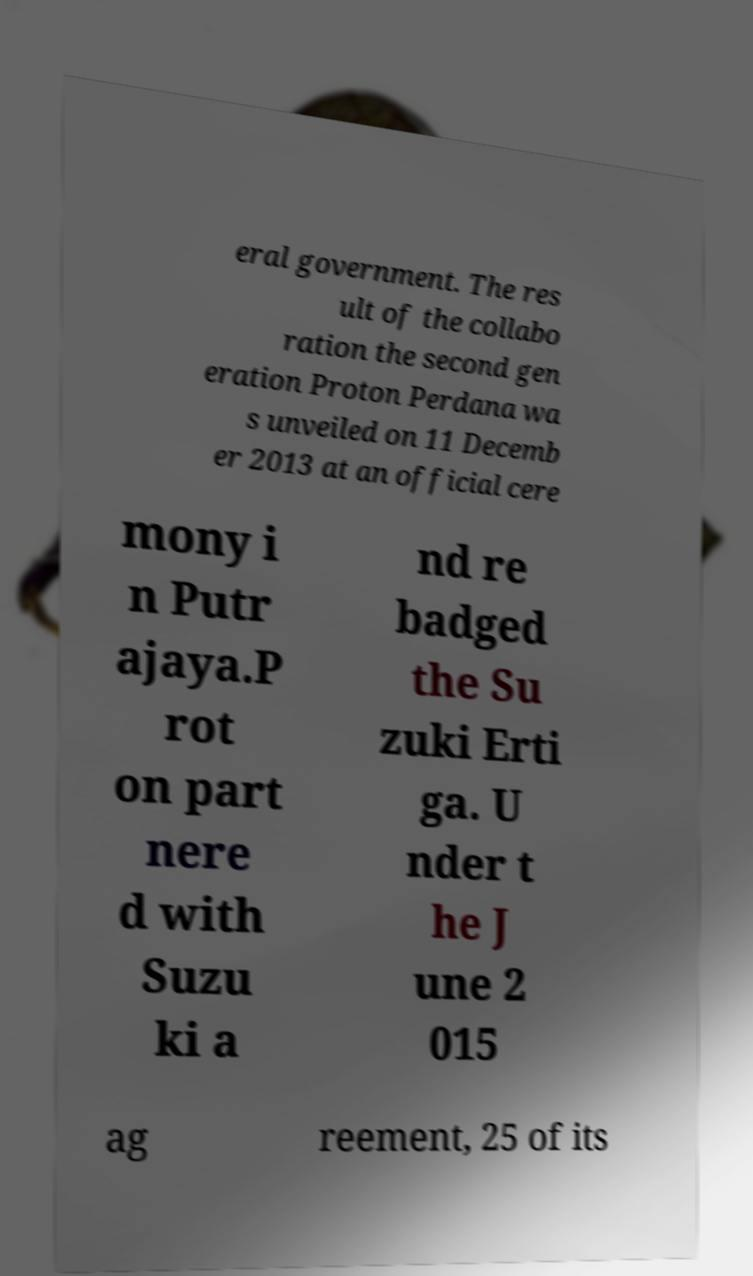There's text embedded in this image that I need extracted. Can you transcribe it verbatim? eral government. The res ult of the collabo ration the second gen eration Proton Perdana wa s unveiled on 11 Decemb er 2013 at an official cere mony i n Putr ajaya.P rot on part nere d with Suzu ki a nd re badged the Su zuki Erti ga. U nder t he J une 2 015 ag reement, 25 of its 